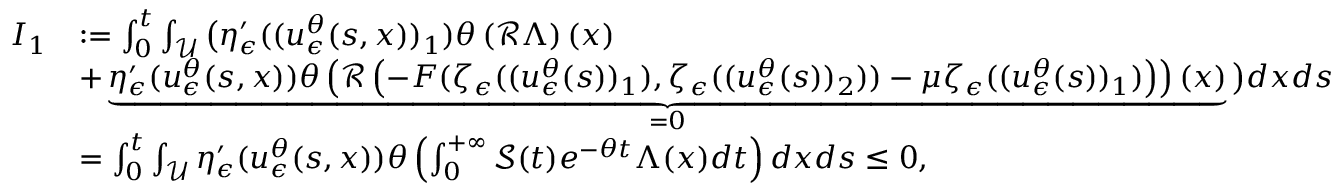Convert formula to latex. <formula><loc_0><loc_0><loc_500><loc_500>\begin{array} { r l } { I _ { 1 } } & { \colon = \int _ { 0 } ^ { t } \int _ { \mathcal { U } } \left ( \eta _ { \epsilon } ^ { \prime } ( ( u _ { \epsilon } ^ { \theta } ( s , x ) ) _ { 1 } ) \theta \left ( \mathcal { R } \Lambda \right ) ( x ) } \\ & { + \underbrace { \eta _ { \epsilon } ^ { \prime } ( u _ { \epsilon } ^ { \theta } ( s , x ) ) \theta \left ( \mathcal { R } \left ( - F ( \zeta _ { \epsilon } ( ( u _ { \epsilon } ^ { \theta } ( s ) ) _ { 1 } ) , \zeta _ { \epsilon } ( ( u _ { \epsilon } ^ { \theta } ( s ) ) _ { 2 } ) ) - \mu \zeta _ { \epsilon } ( ( u _ { \epsilon } ^ { \theta } ( s ) ) _ { 1 } ) \right ) \right ) ( x ) } _ { = 0 } \right ) d x d s } \\ & { = \int _ { 0 } ^ { t } \int _ { \mathcal { U } } \eta _ { \epsilon } ^ { \prime } ( u _ { \epsilon } ^ { \theta } ( s , x ) ) \theta \left ( \int _ { 0 } ^ { + \infty } \mathcal { S } ( t ) e ^ { - \theta t } \Lambda ( x ) d t \right ) d x d s \leq 0 , } \end{array}</formula> 